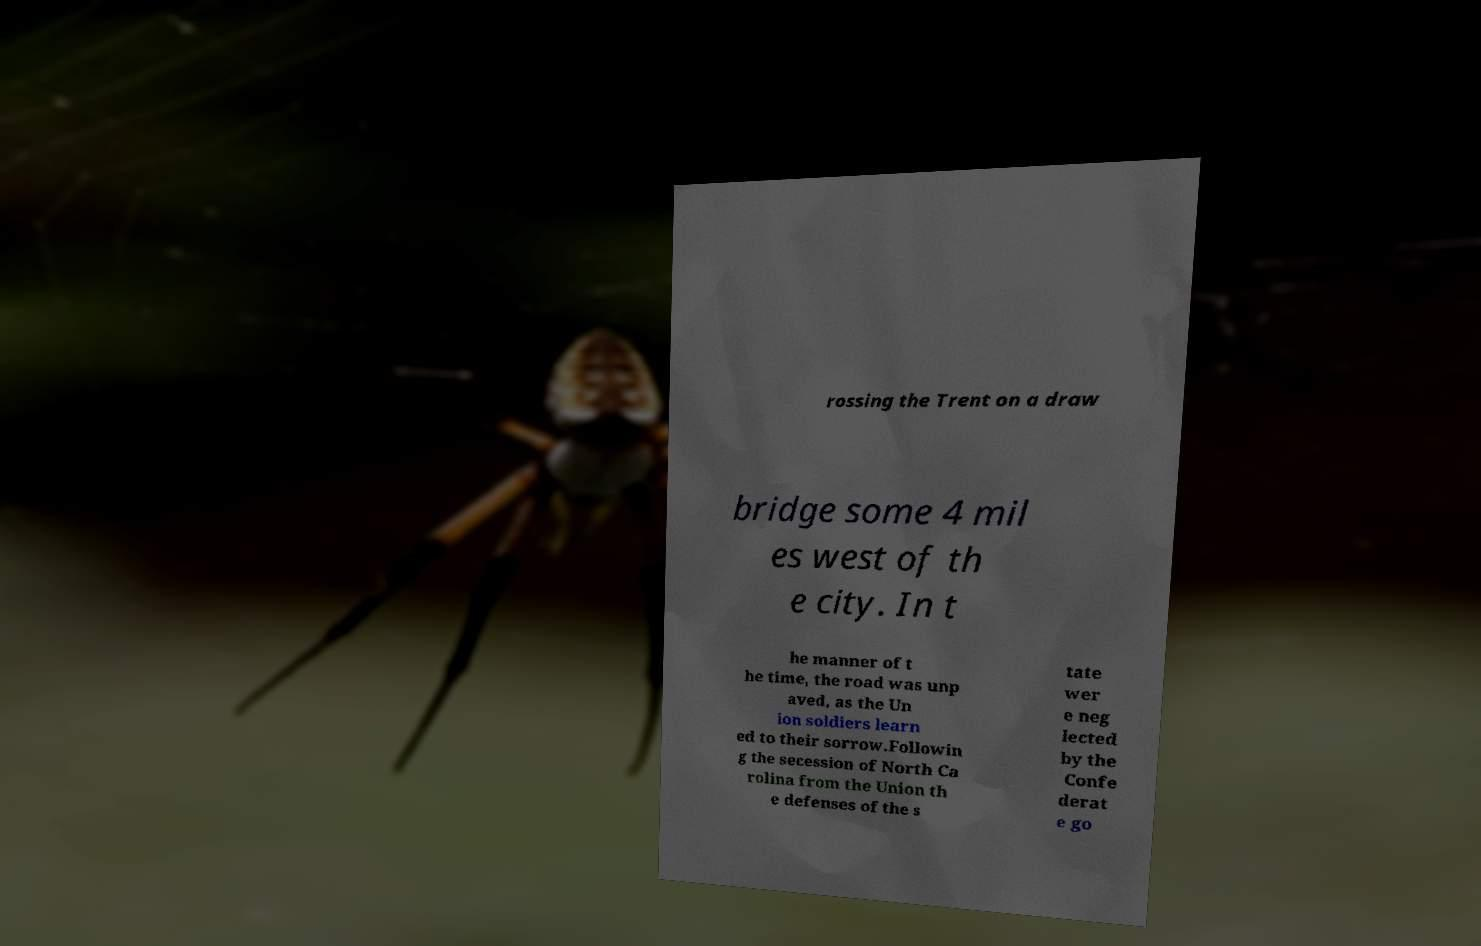Could you assist in decoding the text presented in this image and type it out clearly? rossing the Trent on a draw bridge some 4 mil es west of th e city. In t he manner of t he time, the road was unp aved, as the Un ion soldiers learn ed to their sorrow.Followin g the secession of North Ca rolina from the Union th e defenses of the s tate wer e neg lected by the Confe derat e go 